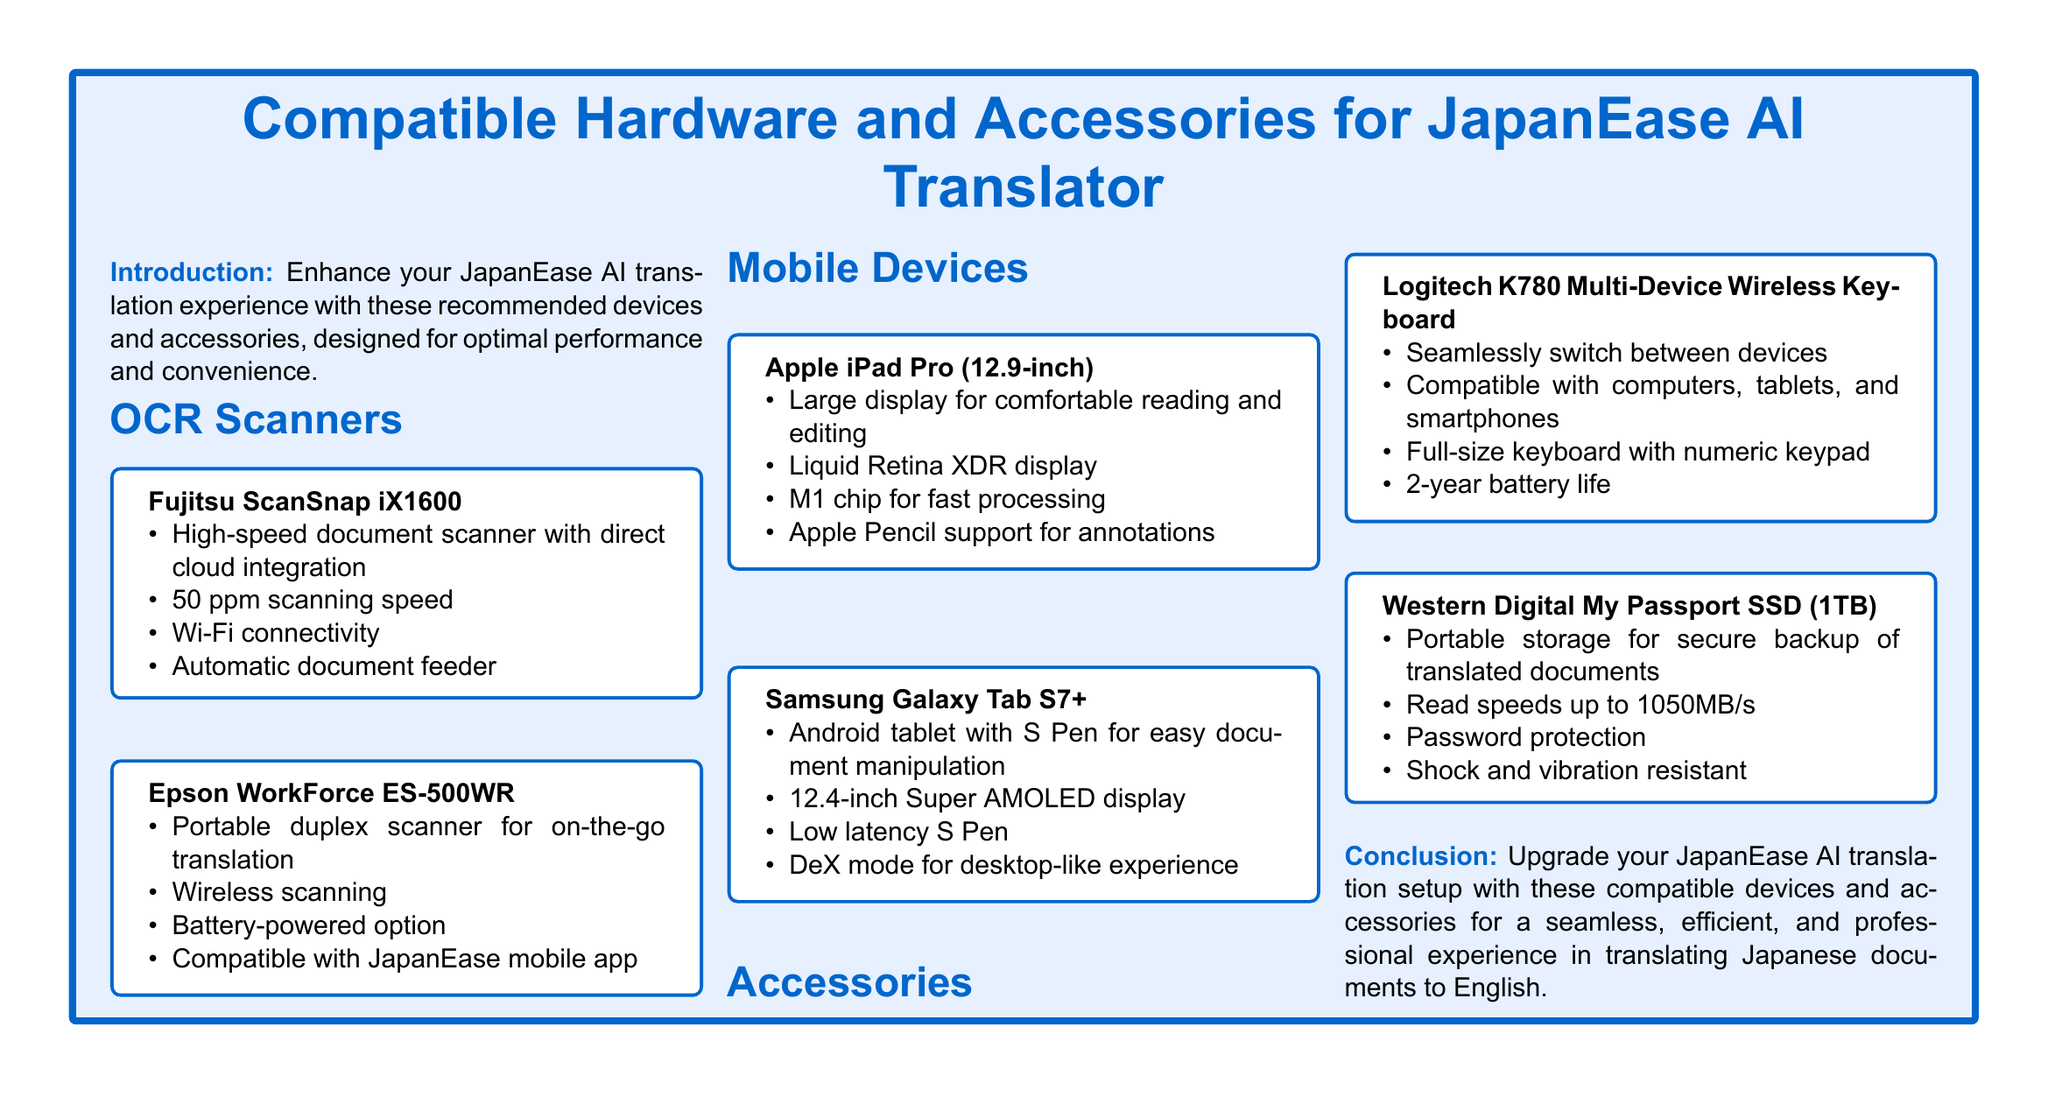What is the scanning speed of Fujitsu ScanSnap iX1600? The scanning speed of Fujitsu ScanSnap iX1600 is mentioned as 50 ppm in the document.
Answer: 50 ppm What is the display size of the Samsung Galaxy Tab S7+? The document states that the Samsung Galaxy Tab S7+ has a 12.4-inch display.
Answer: 12.4-inch Which accessory has a 2-year battery life? According to the document, the Logitech K780 Multi-Device Wireless Keyboard is noted to have a 2-year battery life.
Answer: 2-year What type of protection does the Western Digital My Passport SSD offer? The document mentions that the Western Digital My Passport SSD has password protection.
Answer: Password protection What is a feature that enhances the Apple iPad Pro's usability? The document highlights that the Apple iPad Pro supports Apple Pencil for annotations, enhancing its usability.
Answer: Apple Pencil support Which mobile device supports DeX mode? The document states that the Samsung Galaxy Tab S7+ supports DeX mode for a desktop-like experience.
Answer: DeX mode What is a key benefit of the Epson WorkForce ES-500WR? The document describes the Epson WorkForce ES-500WR as a portable duplex scanner, which is a key benefit.
Answer: Portable duplex scanner What does the conclusion emphasize about device upgrades? The conclusion emphasizes upgrading the translation setup for a seamless experience.
Answer: Seamless experience What type of devices does the Logitech K780 keyboard connect to? The document specifies that the Logitech K780 keyboard is compatible with computers, tablets, and smartphones.
Answer: Computers, tablets, and smartphones 